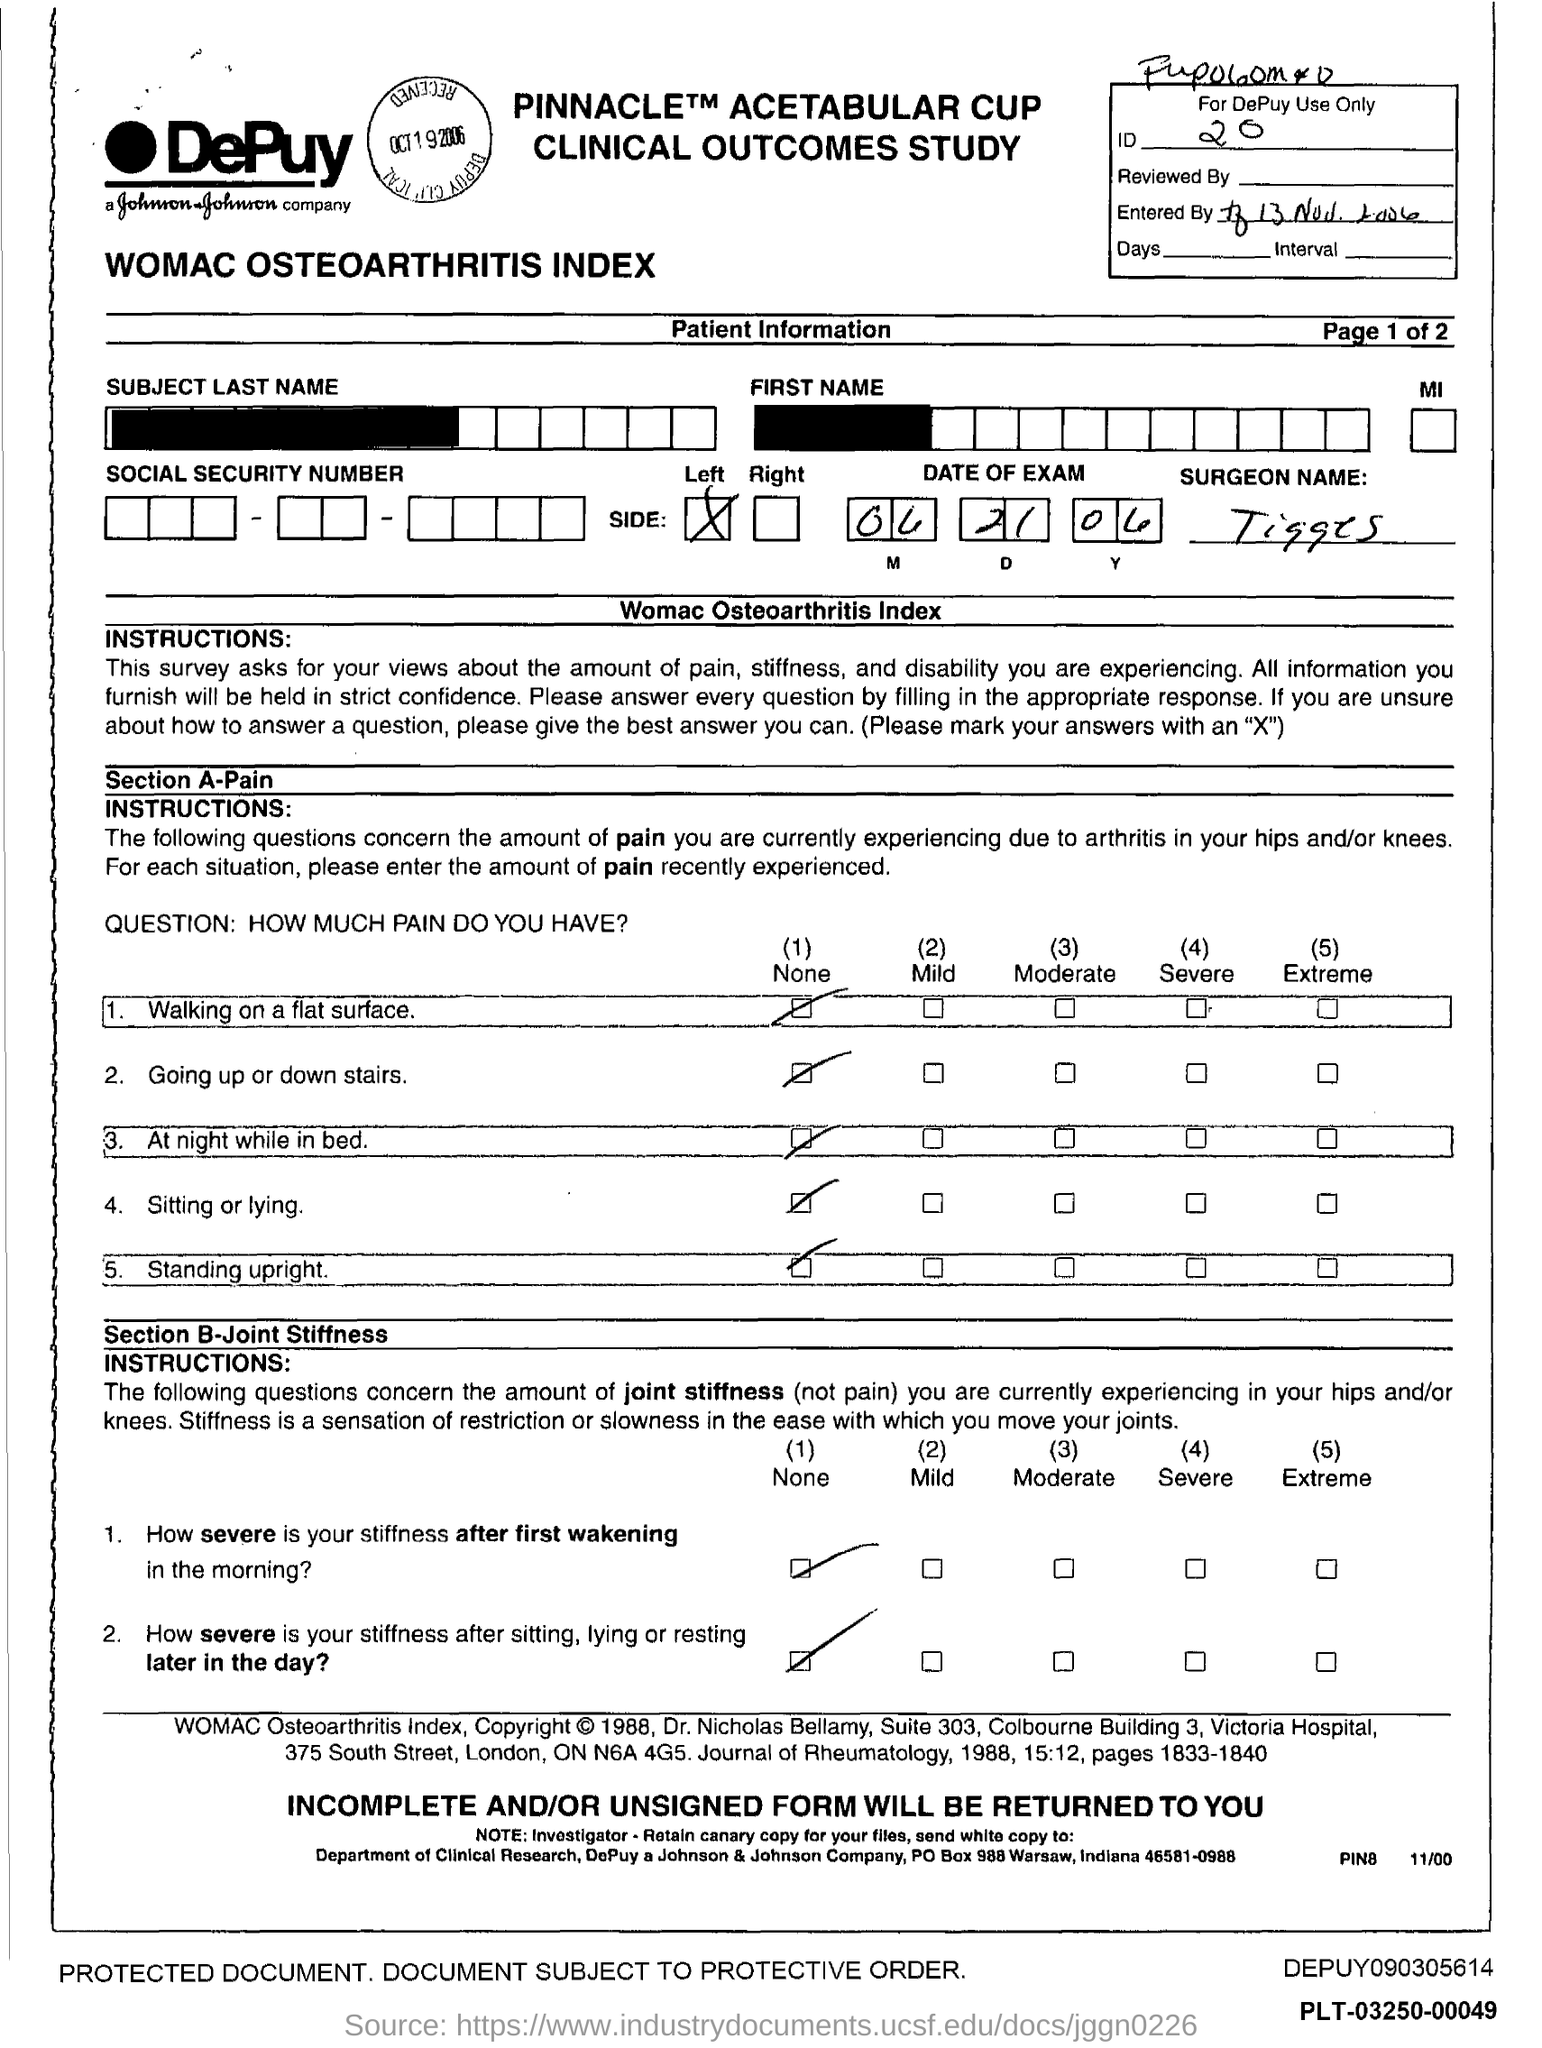What is the id?
Keep it short and to the point. 20. What is the name of the Surgeon?
Your answer should be compact. Tigges. 